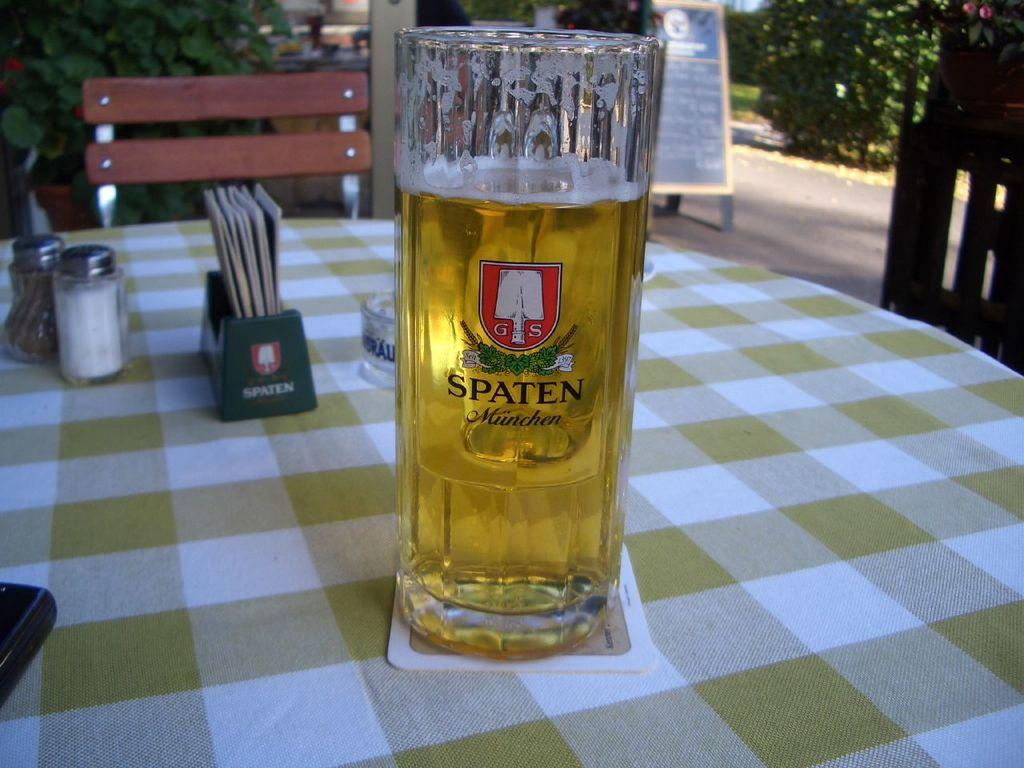Provide a one-sentence caption for the provided image. the word spaten is on the front of the beer. 